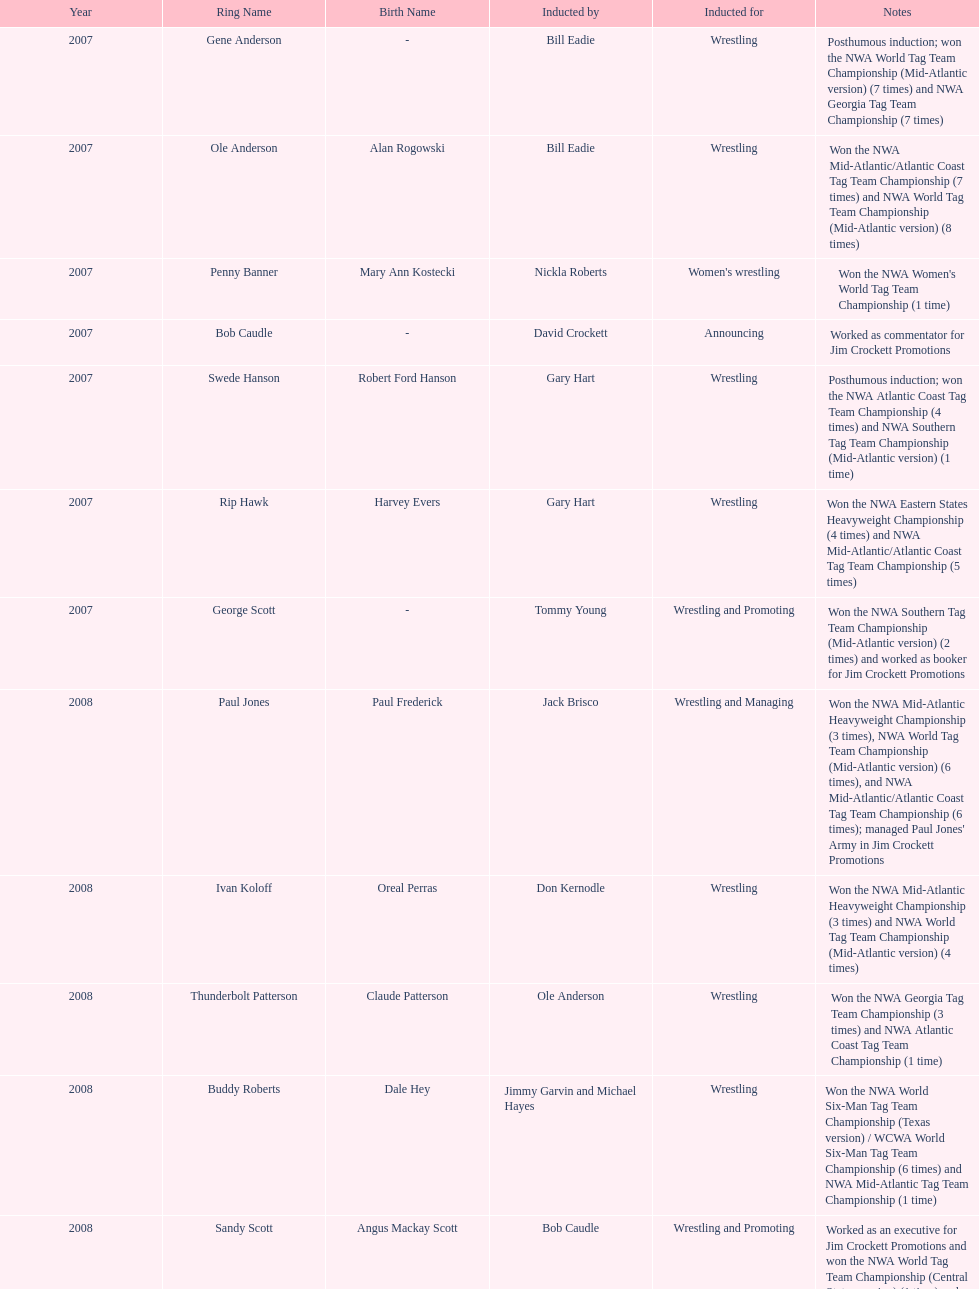Bob caudle was an announcer, who was the other one? Lance Russell. 